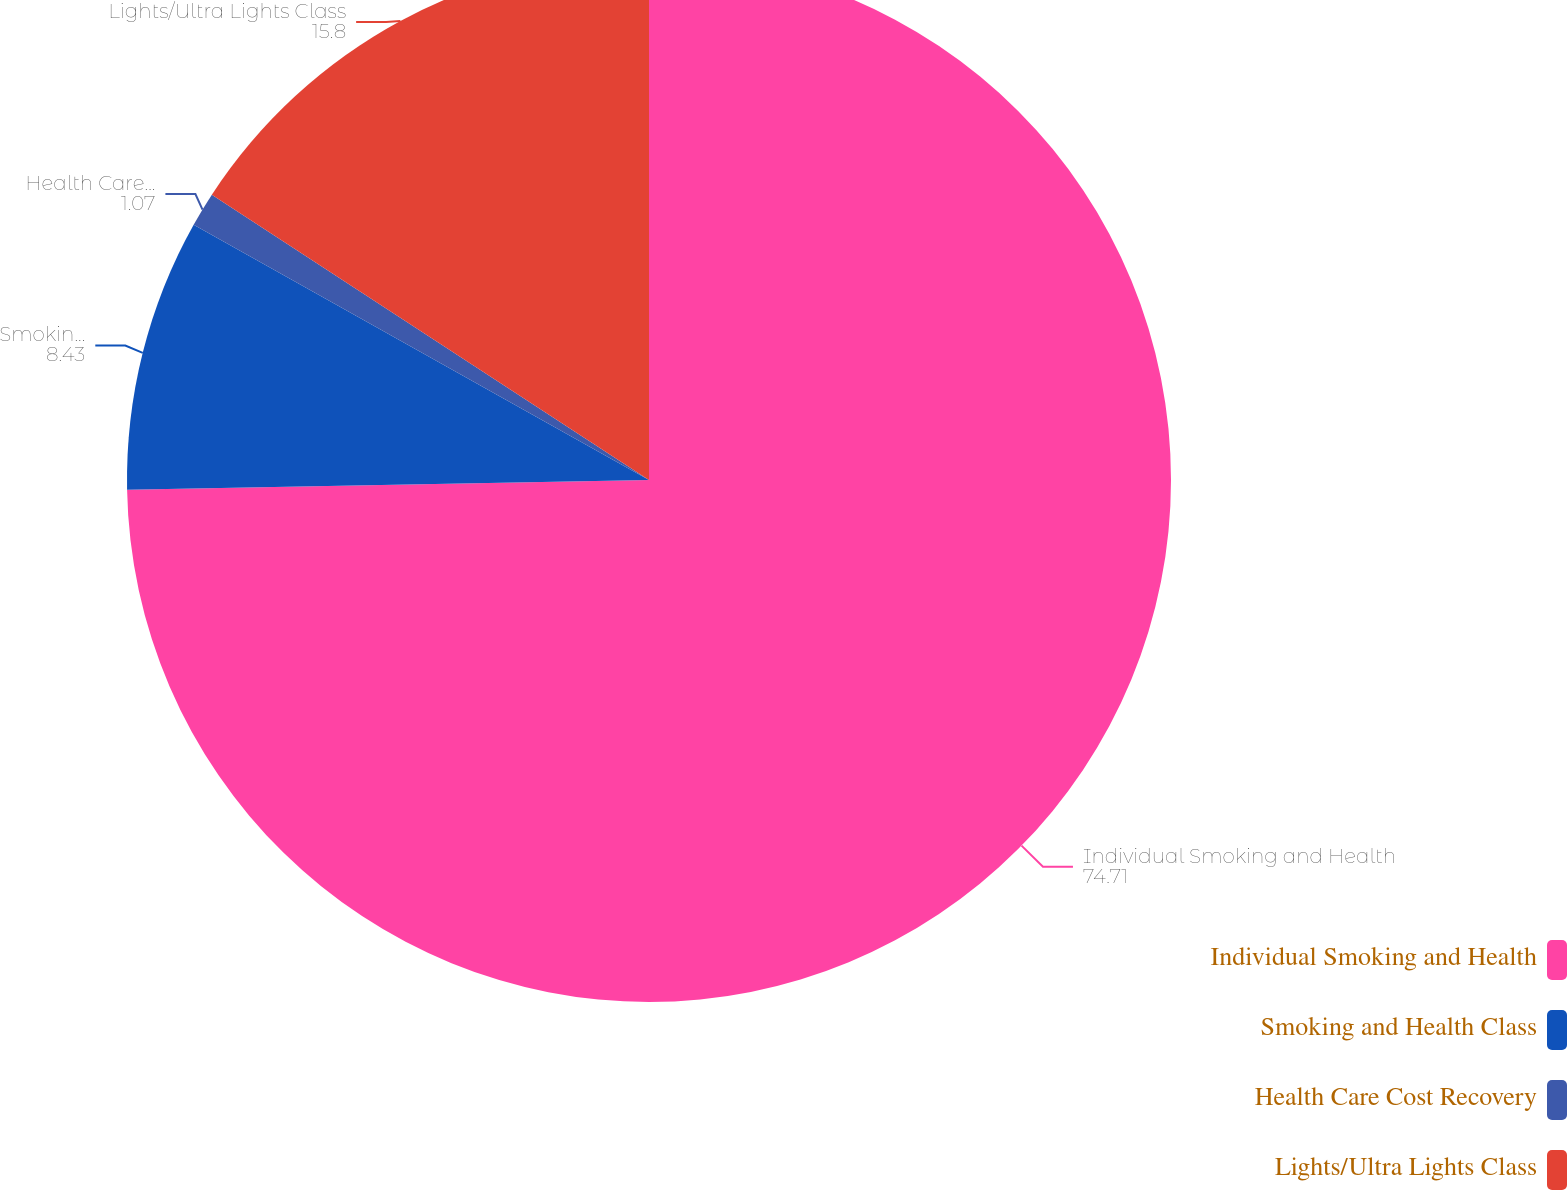Convert chart. <chart><loc_0><loc_0><loc_500><loc_500><pie_chart><fcel>Individual Smoking and Health<fcel>Smoking and Health Class<fcel>Health Care Cost Recovery<fcel>Lights/Ultra Lights Class<nl><fcel>74.71%<fcel>8.43%<fcel>1.07%<fcel>15.8%<nl></chart> 